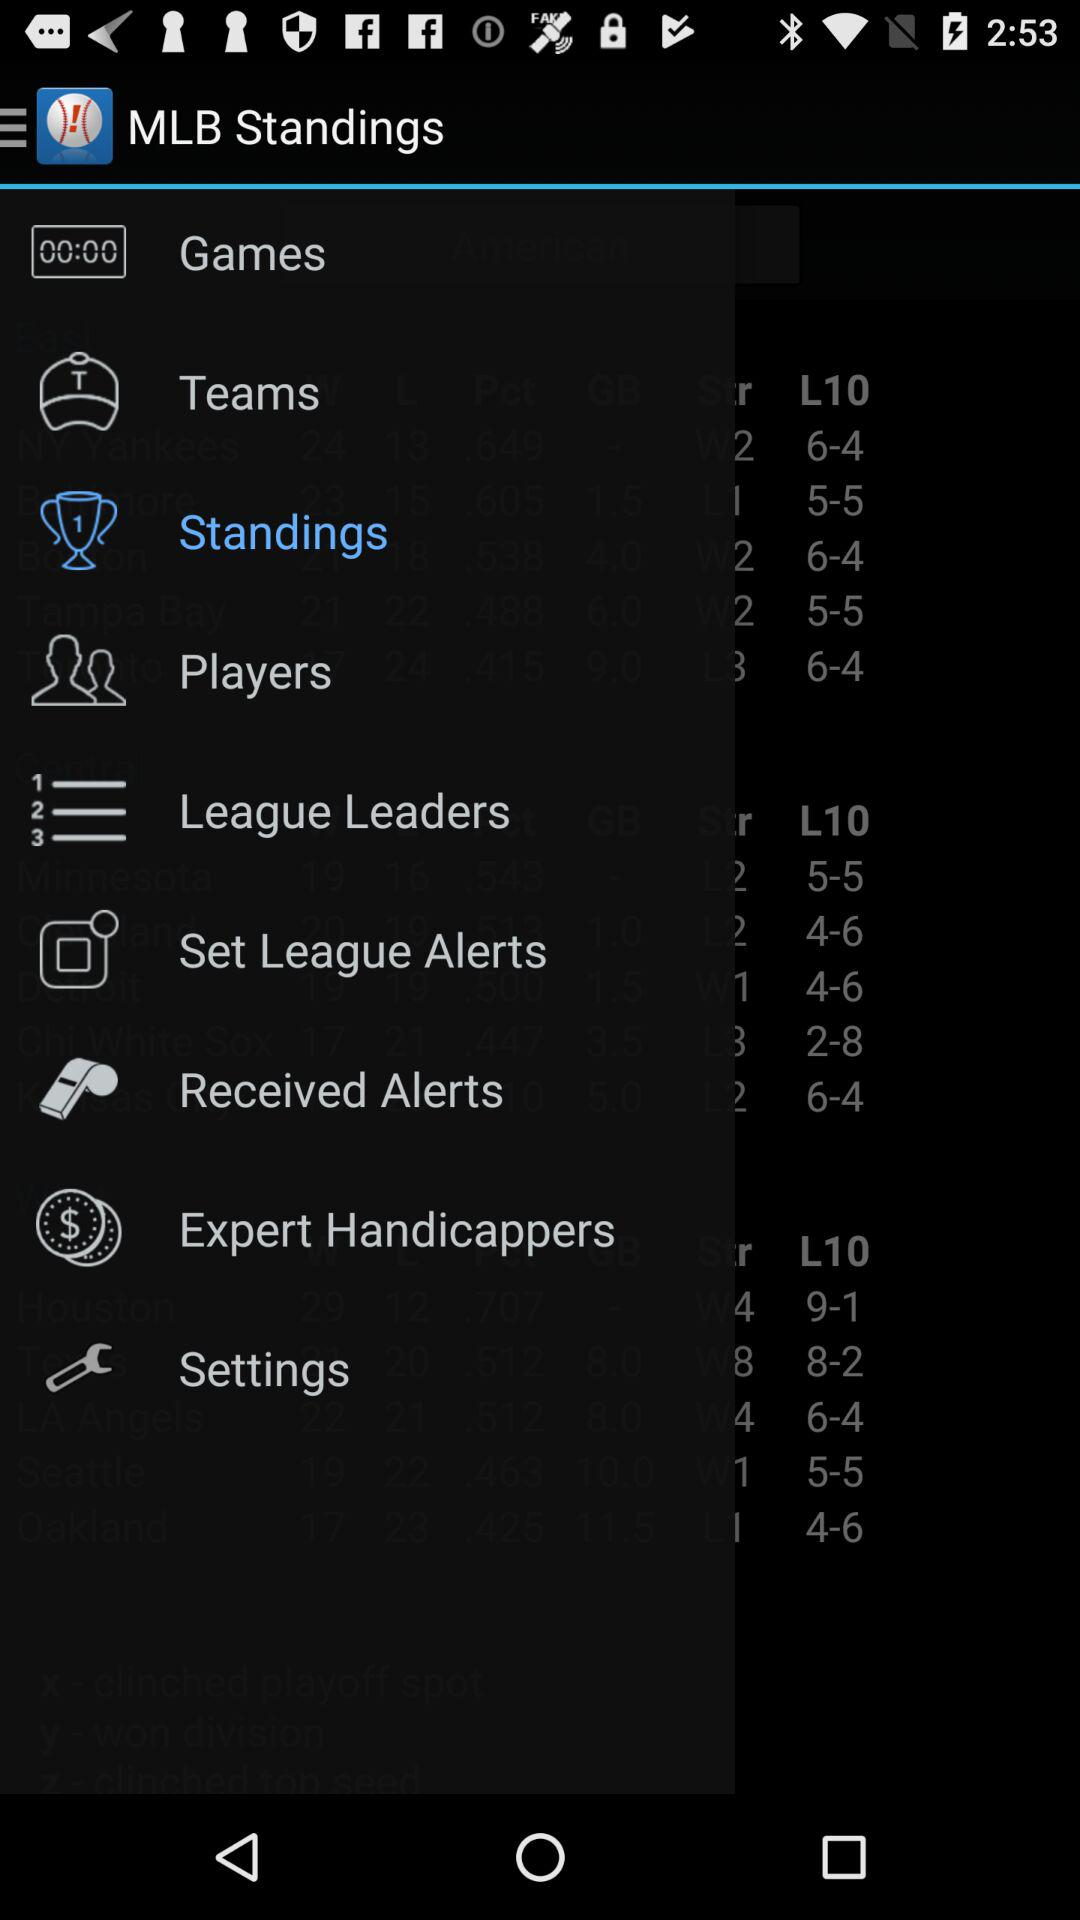What is the application name? The application name is "MLB Standings". 